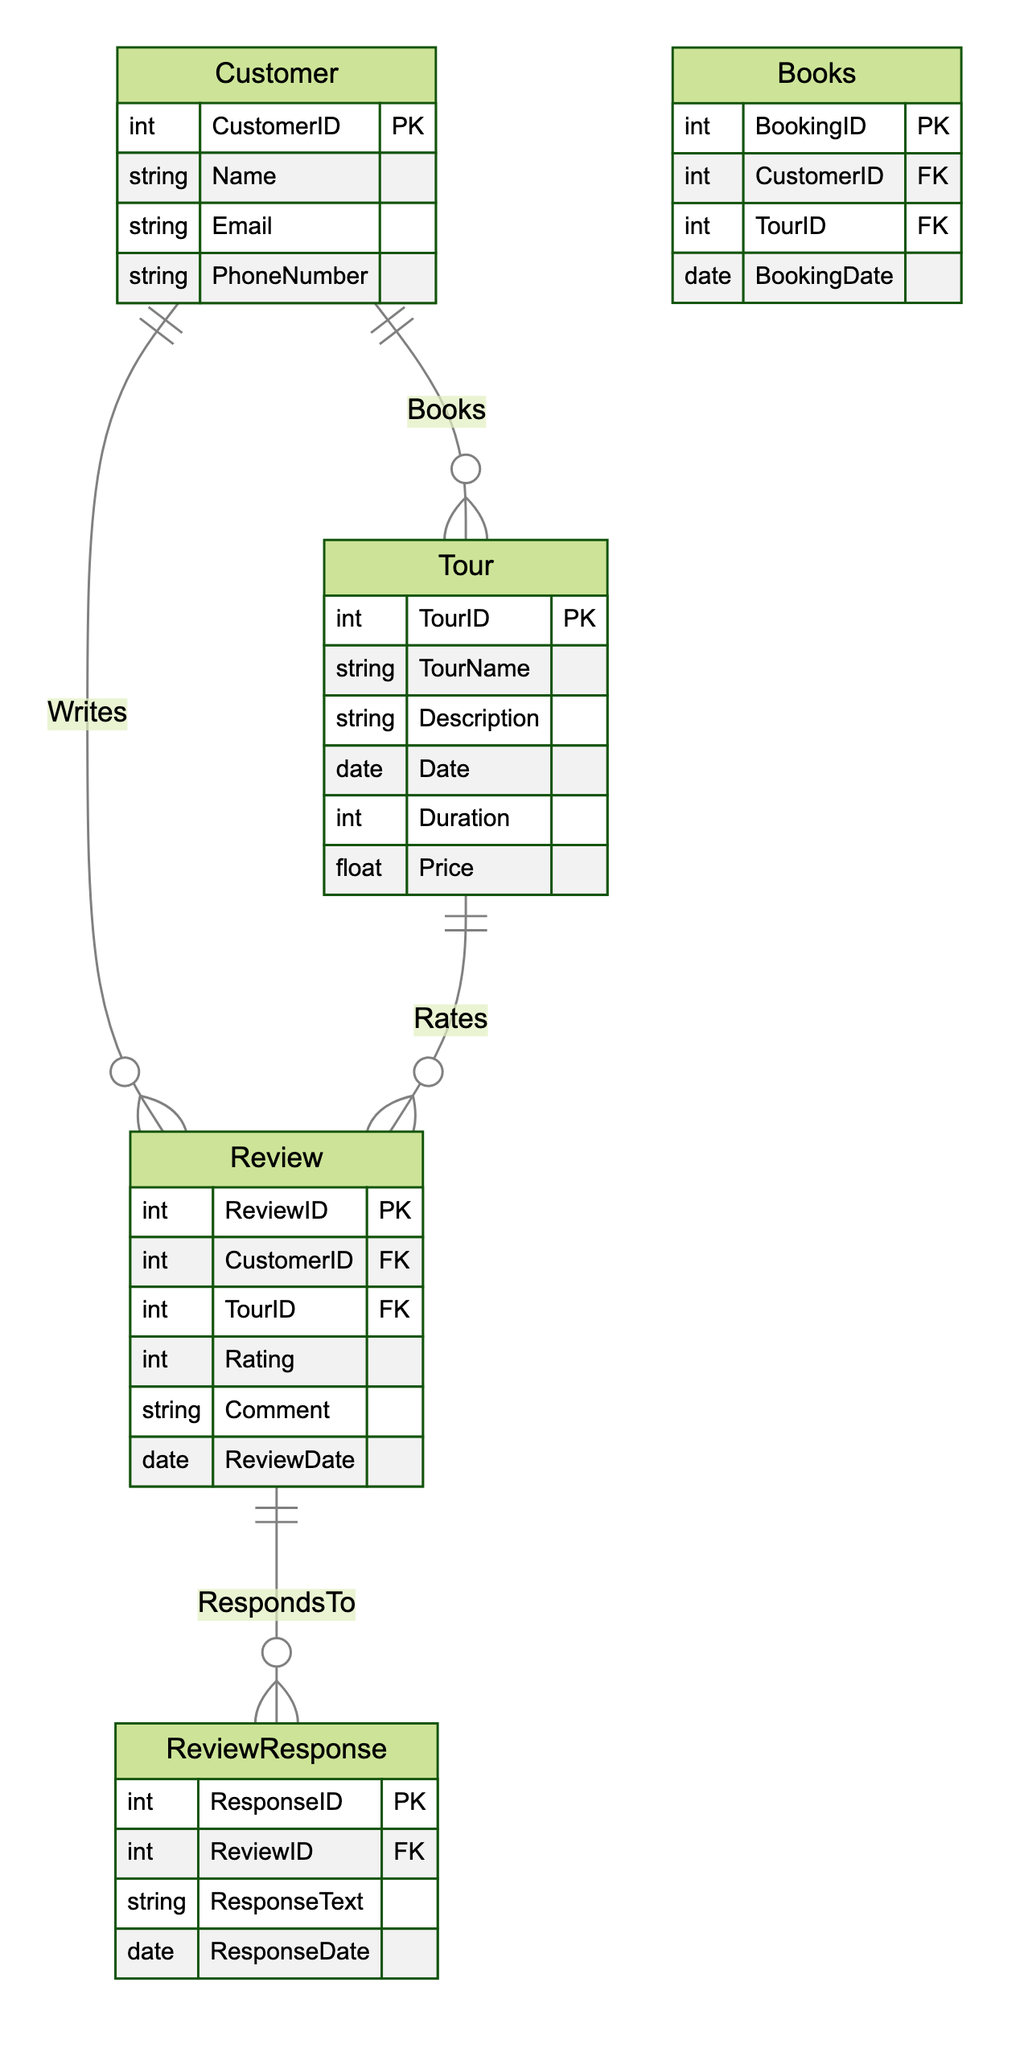What's the primary key of the Customer entity? The Customer entity has a primary key named CustomerID, which uniquely identifies each customer in the system.
Answer: CustomerID How many entities are in the diagram? The diagram contains four entities: Customer, Tour, Review, and ReviewResponse, which can all be listed as separate entities within the diagram.
Answer: Four What relationship connects Customer and Tour? The relationship between Customer and Tour is termed "Books," indicating that a customer can book a tour.
Answer: Books Which entity has a foreign key related to Review? The Review entity has two foreign keys: CustomerID and TourID, linking it to the Customer and Tour entities, respectively.
Answer: Review How many attributes does the ReviewResponse entity have? The ReviewResponse entity contains three attributes: ResponseID, ResponseText, and ResponseDate, which can be counted from the attributes listed under this entity.
Answer: Three What does the Writes relationship represent? The Writes relationship represents that a Customer can write a Review, indicating the interaction between these two entities.
Answer: Customer writes Review Which entity contains a price attribute? The Tour entity includes the Price attribute, which indicates the cost associated with each tour offered.
Answer: Tour What is the relationship type between Review and ReviewResponse? The relationship type between Review and ReviewResponse is "RespondsTo," indicating that responses are made to reviews.
Answer: RespondsTo How many relationships are present in the diagram? There are four relationships illustrated in the diagram, connecting the entities through interactions or actions.
Answer: Four 